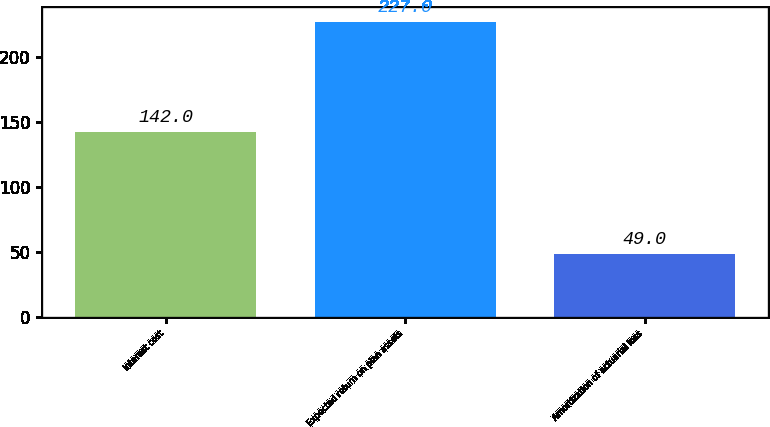<chart> <loc_0><loc_0><loc_500><loc_500><bar_chart><fcel>Interest cost<fcel>Expected return on plan assets<fcel>Amortization of actuarial loss<nl><fcel>142<fcel>227<fcel>49<nl></chart> 